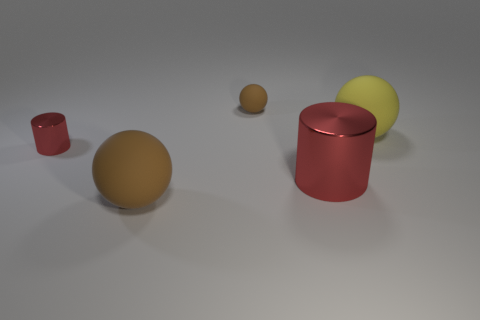The tiny shiny thing has what shape?
Offer a very short reply. Cylinder. Is the color of the shiny object that is on the left side of the small brown matte object the same as the large metal object?
Make the answer very short. Yes. What is the shape of the thing that is in front of the small red cylinder and on the right side of the big brown rubber sphere?
Provide a short and direct response. Cylinder. What color is the large metallic object left of the yellow matte sphere?
Ensure brevity in your answer.  Red. There is a object that is both on the right side of the small rubber object and in front of the tiny red metal object; how big is it?
Provide a succinct answer. Large. How many big balls have the same material as the large brown thing?
Provide a succinct answer. 1. There is a thing that is the same color as the tiny metal cylinder; what shape is it?
Keep it short and to the point. Cylinder. What color is the small matte sphere?
Give a very brief answer. Brown. Is the shape of the big metallic object in front of the small brown rubber object the same as  the tiny red shiny object?
Make the answer very short. Yes. How many objects are red shiny cylinders that are right of the tiny cylinder or big purple matte cylinders?
Offer a very short reply. 1. 